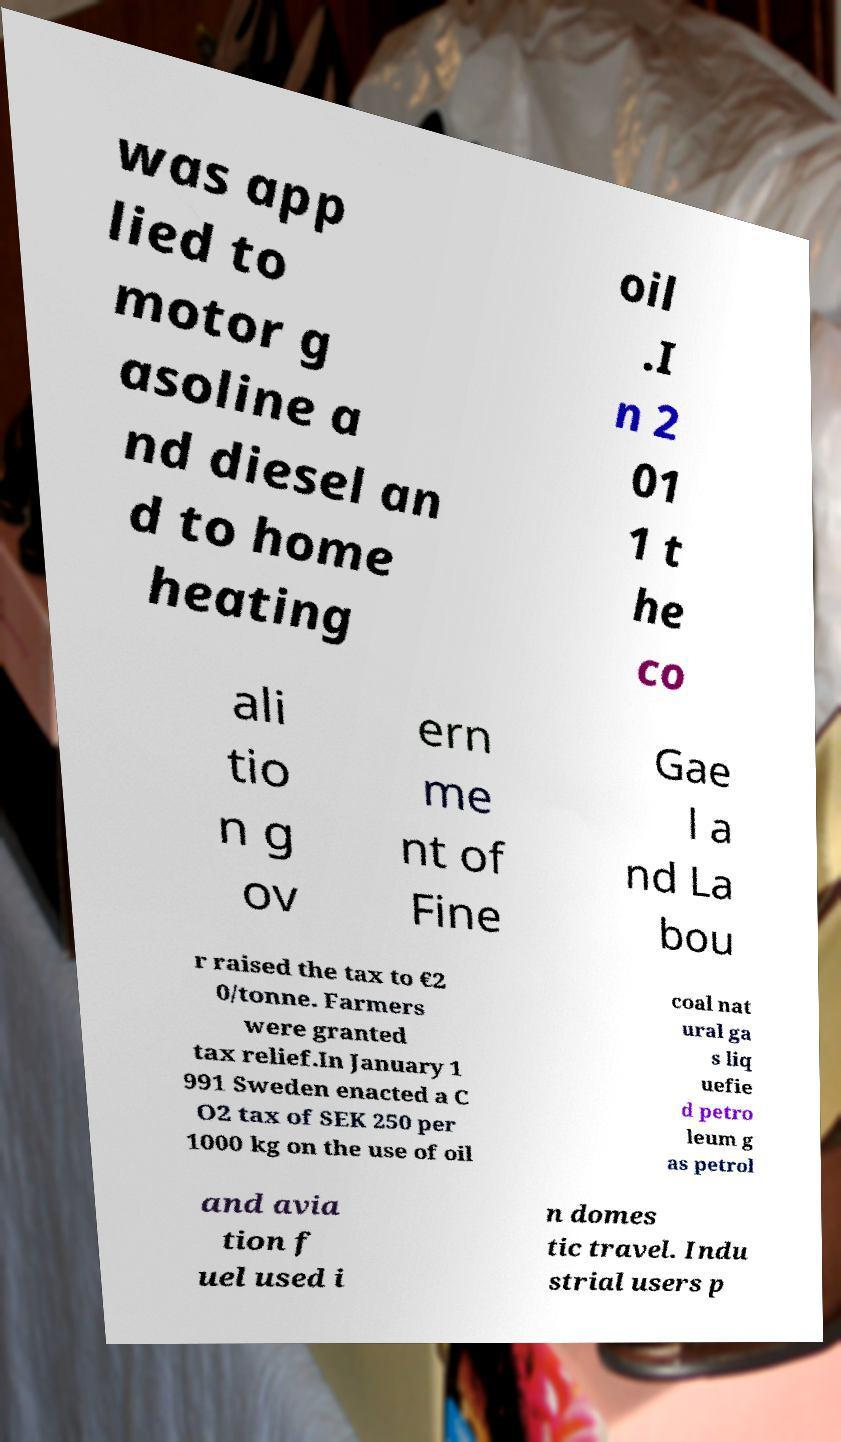For documentation purposes, I need the text within this image transcribed. Could you provide that? was app lied to motor g asoline a nd diesel an d to home heating oil .I n 2 01 1 t he co ali tio n g ov ern me nt of Fine Gae l a nd La bou r raised the tax to €2 0/tonne. Farmers were granted tax relief.In January 1 991 Sweden enacted a C O2 tax of SEK 250 per 1000 kg on the use of oil coal nat ural ga s liq uefie d petro leum g as petrol and avia tion f uel used i n domes tic travel. Indu strial users p 